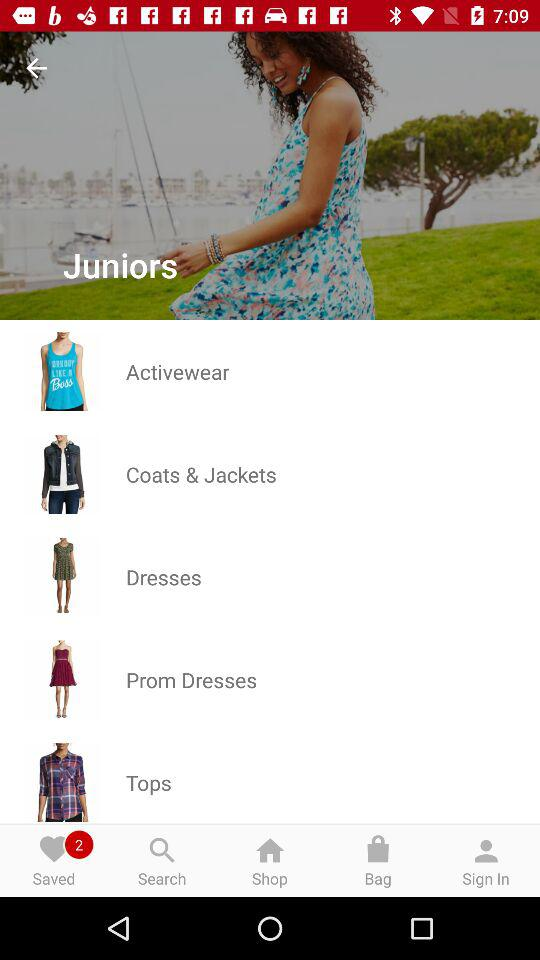How many items are saved? There are 2 items saved. 